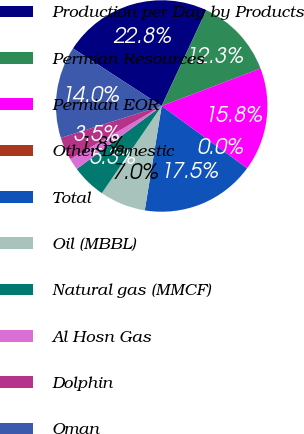<chart> <loc_0><loc_0><loc_500><loc_500><pie_chart><fcel>Production per Day by Products<fcel>Permian Resources<fcel>Permian EOR<fcel>Other Domestic<fcel>Total<fcel>Oil (MBBL)<fcel>Natural gas (MMCF)<fcel>Al Hosn Gas<fcel>Dolphin<fcel>Oman<nl><fcel>22.78%<fcel>12.28%<fcel>15.78%<fcel>0.02%<fcel>17.53%<fcel>7.02%<fcel>5.27%<fcel>1.77%<fcel>3.52%<fcel>14.03%<nl></chart> 